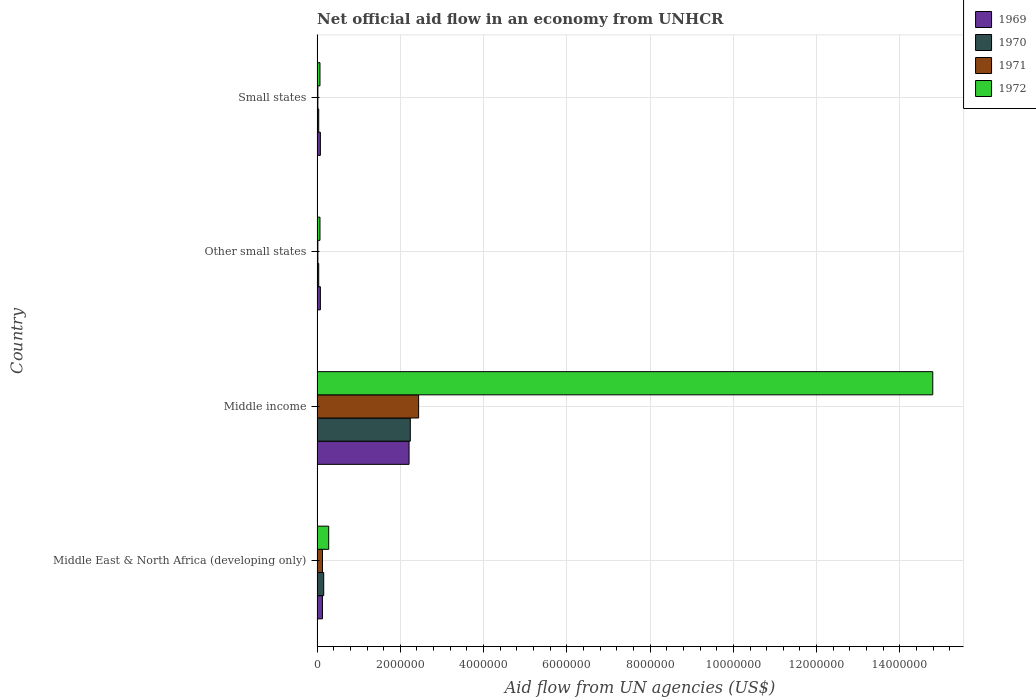How many different coloured bars are there?
Offer a very short reply. 4. Are the number of bars per tick equal to the number of legend labels?
Offer a very short reply. Yes. Are the number of bars on each tick of the Y-axis equal?
Keep it short and to the point. Yes. How many bars are there on the 4th tick from the top?
Offer a very short reply. 4. How many bars are there on the 2nd tick from the bottom?
Ensure brevity in your answer.  4. What is the label of the 2nd group of bars from the top?
Offer a terse response. Other small states. What is the net official aid flow in 1972 in Other small states?
Ensure brevity in your answer.  7.00e+04. Across all countries, what is the maximum net official aid flow in 1971?
Make the answer very short. 2.44e+06. In which country was the net official aid flow in 1970 maximum?
Ensure brevity in your answer.  Middle income. In which country was the net official aid flow in 1971 minimum?
Offer a terse response. Other small states. What is the total net official aid flow in 1971 in the graph?
Your answer should be compact. 2.61e+06. What is the difference between the net official aid flow in 1969 in Middle East & North Africa (developing only) and that in Other small states?
Ensure brevity in your answer.  5.00e+04. What is the average net official aid flow in 1971 per country?
Give a very brief answer. 6.52e+05. What is the difference between the net official aid flow in 1969 and net official aid flow in 1972 in Middle income?
Your response must be concise. -1.26e+07. What is the ratio of the net official aid flow in 1972 in Middle income to that in Other small states?
Your answer should be compact. 211.29. Is the net official aid flow in 1969 in Middle East & North Africa (developing only) less than that in Small states?
Give a very brief answer. No. What is the difference between the highest and the second highest net official aid flow in 1970?
Provide a short and direct response. 2.08e+06. What is the difference between the highest and the lowest net official aid flow in 1969?
Your response must be concise. 2.13e+06. In how many countries, is the net official aid flow in 1972 greater than the average net official aid flow in 1972 taken over all countries?
Your response must be concise. 1. Is the sum of the net official aid flow in 1969 in Middle income and Small states greater than the maximum net official aid flow in 1971 across all countries?
Your answer should be compact. No. Is it the case that in every country, the sum of the net official aid flow in 1969 and net official aid flow in 1970 is greater than the sum of net official aid flow in 1971 and net official aid flow in 1972?
Offer a very short reply. No. What does the 4th bar from the top in Middle East & North Africa (developing only) represents?
Your answer should be very brief. 1969. Are all the bars in the graph horizontal?
Your answer should be very brief. Yes. How many countries are there in the graph?
Offer a terse response. 4. Are the values on the major ticks of X-axis written in scientific E-notation?
Make the answer very short. No. Does the graph contain any zero values?
Ensure brevity in your answer.  No. Does the graph contain grids?
Make the answer very short. Yes. How many legend labels are there?
Give a very brief answer. 4. How are the legend labels stacked?
Make the answer very short. Vertical. What is the title of the graph?
Provide a short and direct response. Net official aid flow in an economy from UNHCR. What is the label or title of the X-axis?
Offer a terse response. Aid flow from UN agencies (US$). What is the Aid flow from UN agencies (US$) of 1969 in Middle East & North Africa (developing only)?
Your answer should be compact. 1.30e+05. What is the Aid flow from UN agencies (US$) in 1971 in Middle East & North Africa (developing only)?
Ensure brevity in your answer.  1.30e+05. What is the Aid flow from UN agencies (US$) in 1969 in Middle income?
Provide a short and direct response. 2.21e+06. What is the Aid flow from UN agencies (US$) of 1970 in Middle income?
Provide a succinct answer. 2.24e+06. What is the Aid flow from UN agencies (US$) of 1971 in Middle income?
Make the answer very short. 2.44e+06. What is the Aid flow from UN agencies (US$) in 1972 in Middle income?
Provide a short and direct response. 1.48e+07. What is the Aid flow from UN agencies (US$) of 1969 in Other small states?
Ensure brevity in your answer.  8.00e+04. What is the Aid flow from UN agencies (US$) in 1970 in Other small states?
Offer a terse response. 4.00e+04. What is the Aid flow from UN agencies (US$) of 1971 in Other small states?
Provide a short and direct response. 2.00e+04. What is the Aid flow from UN agencies (US$) of 1969 in Small states?
Ensure brevity in your answer.  8.00e+04. What is the Aid flow from UN agencies (US$) in 1971 in Small states?
Make the answer very short. 2.00e+04. Across all countries, what is the maximum Aid flow from UN agencies (US$) of 1969?
Provide a short and direct response. 2.21e+06. Across all countries, what is the maximum Aid flow from UN agencies (US$) of 1970?
Keep it short and to the point. 2.24e+06. Across all countries, what is the maximum Aid flow from UN agencies (US$) of 1971?
Keep it short and to the point. 2.44e+06. Across all countries, what is the maximum Aid flow from UN agencies (US$) of 1972?
Ensure brevity in your answer.  1.48e+07. Across all countries, what is the minimum Aid flow from UN agencies (US$) of 1969?
Provide a succinct answer. 8.00e+04. Across all countries, what is the minimum Aid flow from UN agencies (US$) in 1970?
Offer a very short reply. 4.00e+04. Across all countries, what is the minimum Aid flow from UN agencies (US$) of 1972?
Your response must be concise. 7.00e+04. What is the total Aid flow from UN agencies (US$) of 1969 in the graph?
Keep it short and to the point. 2.50e+06. What is the total Aid flow from UN agencies (US$) of 1970 in the graph?
Offer a very short reply. 2.48e+06. What is the total Aid flow from UN agencies (US$) of 1971 in the graph?
Provide a short and direct response. 2.61e+06. What is the total Aid flow from UN agencies (US$) of 1972 in the graph?
Provide a succinct answer. 1.52e+07. What is the difference between the Aid flow from UN agencies (US$) in 1969 in Middle East & North Africa (developing only) and that in Middle income?
Your response must be concise. -2.08e+06. What is the difference between the Aid flow from UN agencies (US$) in 1970 in Middle East & North Africa (developing only) and that in Middle income?
Provide a short and direct response. -2.08e+06. What is the difference between the Aid flow from UN agencies (US$) in 1971 in Middle East & North Africa (developing only) and that in Middle income?
Your answer should be compact. -2.31e+06. What is the difference between the Aid flow from UN agencies (US$) of 1972 in Middle East & North Africa (developing only) and that in Middle income?
Ensure brevity in your answer.  -1.45e+07. What is the difference between the Aid flow from UN agencies (US$) in 1969 in Middle East & North Africa (developing only) and that in Other small states?
Your response must be concise. 5.00e+04. What is the difference between the Aid flow from UN agencies (US$) in 1970 in Middle East & North Africa (developing only) and that in Other small states?
Keep it short and to the point. 1.20e+05. What is the difference between the Aid flow from UN agencies (US$) in 1972 in Middle East & North Africa (developing only) and that in Other small states?
Ensure brevity in your answer.  2.10e+05. What is the difference between the Aid flow from UN agencies (US$) in 1970 in Middle East & North Africa (developing only) and that in Small states?
Keep it short and to the point. 1.20e+05. What is the difference between the Aid flow from UN agencies (US$) in 1971 in Middle East & North Africa (developing only) and that in Small states?
Offer a very short reply. 1.10e+05. What is the difference between the Aid flow from UN agencies (US$) of 1969 in Middle income and that in Other small states?
Provide a short and direct response. 2.13e+06. What is the difference between the Aid flow from UN agencies (US$) in 1970 in Middle income and that in Other small states?
Provide a succinct answer. 2.20e+06. What is the difference between the Aid flow from UN agencies (US$) of 1971 in Middle income and that in Other small states?
Keep it short and to the point. 2.42e+06. What is the difference between the Aid flow from UN agencies (US$) of 1972 in Middle income and that in Other small states?
Make the answer very short. 1.47e+07. What is the difference between the Aid flow from UN agencies (US$) of 1969 in Middle income and that in Small states?
Your answer should be very brief. 2.13e+06. What is the difference between the Aid flow from UN agencies (US$) of 1970 in Middle income and that in Small states?
Your answer should be compact. 2.20e+06. What is the difference between the Aid flow from UN agencies (US$) in 1971 in Middle income and that in Small states?
Your answer should be very brief. 2.42e+06. What is the difference between the Aid flow from UN agencies (US$) in 1972 in Middle income and that in Small states?
Offer a very short reply. 1.47e+07. What is the difference between the Aid flow from UN agencies (US$) of 1969 in Other small states and that in Small states?
Provide a short and direct response. 0. What is the difference between the Aid flow from UN agencies (US$) of 1969 in Middle East & North Africa (developing only) and the Aid flow from UN agencies (US$) of 1970 in Middle income?
Give a very brief answer. -2.11e+06. What is the difference between the Aid flow from UN agencies (US$) of 1969 in Middle East & North Africa (developing only) and the Aid flow from UN agencies (US$) of 1971 in Middle income?
Keep it short and to the point. -2.31e+06. What is the difference between the Aid flow from UN agencies (US$) of 1969 in Middle East & North Africa (developing only) and the Aid flow from UN agencies (US$) of 1972 in Middle income?
Make the answer very short. -1.47e+07. What is the difference between the Aid flow from UN agencies (US$) in 1970 in Middle East & North Africa (developing only) and the Aid flow from UN agencies (US$) in 1971 in Middle income?
Provide a succinct answer. -2.28e+06. What is the difference between the Aid flow from UN agencies (US$) of 1970 in Middle East & North Africa (developing only) and the Aid flow from UN agencies (US$) of 1972 in Middle income?
Your answer should be very brief. -1.46e+07. What is the difference between the Aid flow from UN agencies (US$) in 1971 in Middle East & North Africa (developing only) and the Aid flow from UN agencies (US$) in 1972 in Middle income?
Your response must be concise. -1.47e+07. What is the difference between the Aid flow from UN agencies (US$) of 1969 in Middle East & North Africa (developing only) and the Aid flow from UN agencies (US$) of 1970 in Other small states?
Keep it short and to the point. 9.00e+04. What is the difference between the Aid flow from UN agencies (US$) of 1969 in Middle East & North Africa (developing only) and the Aid flow from UN agencies (US$) of 1972 in Other small states?
Your answer should be very brief. 6.00e+04. What is the difference between the Aid flow from UN agencies (US$) of 1970 in Middle East & North Africa (developing only) and the Aid flow from UN agencies (US$) of 1971 in Other small states?
Give a very brief answer. 1.40e+05. What is the difference between the Aid flow from UN agencies (US$) in 1971 in Middle East & North Africa (developing only) and the Aid flow from UN agencies (US$) in 1972 in Other small states?
Keep it short and to the point. 6.00e+04. What is the difference between the Aid flow from UN agencies (US$) in 1969 in Middle East & North Africa (developing only) and the Aid flow from UN agencies (US$) in 1970 in Small states?
Your response must be concise. 9.00e+04. What is the difference between the Aid flow from UN agencies (US$) of 1969 in Middle East & North Africa (developing only) and the Aid flow from UN agencies (US$) of 1972 in Small states?
Your response must be concise. 6.00e+04. What is the difference between the Aid flow from UN agencies (US$) of 1970 in Middle East & North Africa (developing only) and the Aid flow from UN agencies (US$) of 1971 in Small states?
Provide a short and direct response. 1.40e+05. What is the difference between the Aid flow from UN agencies (US$) of 1970 in Middle East & North Africa (developing only) and the Aid flow from UN agencies (US$) of 1972 in Small states?
Ensure brevity in your answer.  9.00e+04. What is the difference between the Aid flow from UN agencies (US$) in 1971 in Middle East & North Africa (developing only) and the Aid flow from UN agencies (US$) in 1972 in Small states?
Offer a very short reply. 6.00e+04. What is the difference between the Aid flow from UN agencies (US$) in 1969 in Middle income and the Aid flow from UN agencies (US$) in 1970 in Other small states?
Your answer should be very brief. 2.17e+06. What is the difference between the Aid flow from UN agencies (US$) in 1969 in Middle income and the Aid flow from UN agencies (US$) in 1971 in Other small states?
Provide a short and direct response. 2.19e+06. What is the difference between the Aid flow from UN agencies (US$) in 1969 in Middle income and the Aid flow from UN agencies (US$) in 1972 in Other small states?
Provide a short and direct response. 2.14e+06. What is the difference between the Aid flow from UN agencies (US$) of 1970 in Middle income and the Aid flow from UN agencies (US$) of 1971 in Other small states?
Provide a short and direct response. 2.22e+06. What is the difference between the Aid flow from UN agencies (US$) of 1970 in Middle income and the Aid flow from UN agencies (US$) of 1972 in Other small states?
Provide a short and direct response. 2.17e+06. What is the difference between the Aid flow from UN agencies (US$) of 1971 in Middle income and the Aid flow from UN agencies (US$) of 1972 in Other small states?
Make the answer very short. 2.37e+06. What is the difference between the Aid flow from UN agencies (US$) in 1969 in Middle income and the Aid flow from UN agencies (US$) in 1970 in Small states?
Provide a short and direct response. 2.17e+06. What is the difference between the Aid flow from UN agencies (US$) in 1969 in Middle income and the Aid flow from UN agencies (US$) in 1971 in Small states?
Your answer should be compact. 2.19e+06. What is the difference between the Aid flow from UN agencies (US$) of 1969 in Middle income and the Aid flow from UN agencies (US$) of 1972 in Small states?
Make the answer very short. 2.14e+06. What is the difference between the Aid flow from UN agencies (US$) of 1970 in Middle income and the Aid flow from UN agencies (US$) of 1971 in Small states?
Give a very brief answer. 2.22e+06. What is the difference between the Aid flow from UN agencies (US$) in 1970 in Middle income and the Aid flow from UN agencies (US$) in 1972 in Small states?
Your answer should be compact. 2.17e+06. What is the difference between the Aid flow from UN agencies (US$) in 1971 in Middle income and the Aid flow from UN agencies (US$) in 1972 in Small states?
Give a very brief answer. 2.37e+06. What is the difference between the Aid flow from UN agencies (US$) in 1970 in Other small states and the Aid flow from UN agencies (US$) in 1971 in Small states?
Offer a very short reply. 2.00e+04. What is the difference between the Aid flow from UN agencies (US$) of 1971 in Other small states and the Aid flow from UN agencies (US$) of 1972 in Small states?
Your answer should be compact. -5.00e+04. What is the average Aid flow from UN agencies (US$) of 1969 per country?
Make the answer very short. 6.25e+05. What is the average Aid flow from UN agencies (US$) in 1970 per country?
Your response must be concise. 6.20e+05. What is the average Aid flow from UN agencies (US$) in 1971 per country?
Your answer should be very brief. 6.52e+05. What is the average Aid flow from UN agencies (US$) in 1972 per country?
Your answer should be compact. 3.80e+06. What is the difference between the Aid flow from UN agencies (US$) in 1970 and Aid flow from UN agencies (US$) in 1972 in Middle East & North Africa (developing only)?
Provide a succinct answer. -1.20e+05. What is the difference between the Aid flow from UN agencies (US$) of 1971 and Aid flow from UN agencies (US$) of 1972 in Middle East & North Africa (developing only)?
Provide a short and direct response. -1.50e+05. What is the difference between the Aid flow from UN agencies (US$) of 1969 and Aid flow from UN agencies (US$) of 1970 in Middle income?
Ensure brevity in your answer.  -3.00e+04. What is the difference between the Aid flow from UN agencies (US$) of 1969 and Aid flow from UN agencies (US$) of 1972 in Middle income?
Offer a very short reply. -1.26e+07. What is the difference between the Aid flow from UN agencies (US$) of 1970 and Aid flow from UN agencies (US$) of 1971 in Middle income?
Offer a very short reply. -2.00e+05. What is the difference between the Aid flow from UN agencies (US$) of 1970 and Aid flow from UN agencies (US$) of 1972 in Middle income?
Offer a terse response. -1.26e+07. What is the difference between the Aid flow from UN agencies (US$) of 1971 and Aid flow from UN agencies (US$) of 1972 in Middle income?
Make the answer very short. -1.24e+07. What is the difference between the Aid flow from UN agencies (US$) of 1969 and Aid flow from UN agencies (US$) of 1970 in Other small states?
Make the answer very short. 4.00e+04. What is the difference between the Aid flow from UN agencies (US$) of 1969 and Aid flow from UN agencies (US$) of 1972 in Other small states?
Your answer should be compact. 10000. What is the difference between the Aid flow from UN agencies (US$) in 1970 and Aid flow from UN agencies (US$) in 1972 in Other small states?
Your answer should be compact. -3.00e+04. What is the difference between the Aid flow from UN agencies (US$) in 1969 and Aid flow from UN agencies (US$) in 1971 in Small states?
Give a very brief answer. 6.00e+04. What is the difference between the Aid flow from UN agencies (US$) of 1969 and Aid flow from UN agencies (US$) of 1972 in Small states?
Provide a short and direct response. 10000. What is the difference between the Aid flow from UN agencies (US$) of 1970 and Aid flow from UN agencies (US$) of 1971 in Small states?
Your response must be concise. 2.00e+04. What is the difference between the Aid flow from UN agencies (US$) of 1970 and Aid flow from UN agencies (US$) of 1972 in Small states?
Provide a succinct answer. -3.00e+04. What is the ratio of the Aid flow from UN agencies (US$) in 1969 in Middle East & North Africa (developing only) to that in Middle income?
Offer a terse response. 0.06. What is the ratio of the Aid flow from UN agencies (US$) in 1970 in Middle East & North Africa (developing only) to that in Middle income?
Provide a short and direct response. 0.07. What is the ratio of the Aid flow from UN agencies (US$) of 1971 in Middle East & North Africa (developing only) to that in Middle income?
Provide a short and direct response. 0.05. What is the ratio of the Aid flow from UN agencies (US$) in 1972 in Middle East & North Africa (developing only) to that in Middle income?
Your answer should be compact. 0.02. What is the ratio of the Aid flow from UN agencies (US$) of 1969 in Middle East & North Africa (developing only) to that in Other small states?
Provide a succinct answer. 1.62. What is the ratio of the Aid flow from UN agencies (US$) in 1970 in Middle East & North Africa (developing only) to that in Other small states?
Ensure brevity in your answer.  4. What is the ratio of the Aid flow from UN agencies (US$) in 1969 in Middle East & North Africa (developing only) to that in Small states?
Your answer should be very brief. 1.62. What is the ratio of the Aid flow from UN agencies (US$) in 1972 in Middle East & North Africa (developing only) to that in Small states?
Your answer should be compact. 4. What is the ratio of the Aid flow from UN agencies (US$) of 1969 in Middle income to that in Other small states?
Your answer should be very brief. 27.62. What is the ratio of the Aid flow from UN agencies (US$) of 1971 in Middle income to that in Other small states?
Provide a succinct answer. 122. What is the ratio of the Aid flow from UN agencies (US$) of 1972 in Middle income to that in Other small states?
Keep it short and to the point. 211.29. What is the ratio of the Aid flow from UN agencies (US$) in 1969 in Middle income to that in Small states?
Offer a very short reply. 27.62. What is the ratio of the Aid flow from UN agencies (US$) of 1971 in Middle income to that in Small states?
Keep it short and to the point. 122. What is the ratio of the Aid flow from UN agencies (US$) in 1972 in Middle income to that in Small states?
Keep it short and to the point. 211.29. What is the ratio of the Aid flow from UN agencies (US$) of 1969 in Other small states to that in Small states?
Provide a succinct answer. 1. What is the ratio of the Aid flow from UN agencies (US$) in 1970 in Other small states to that in Small states?
Provide a short and direct response. 1. What is the ratio of the Aid flow from UN agencies (US$) of 1971 in Other small states to that in Small states?
Give a very brief answer. 1. What is the difference between the highest and the second highest Aid flow from UN agencies (US$) of 1969?
Your answer should be compact. 2.08e+06. What is the difference between the highest and the second highest Aid flow from UN agencies (US$) in 1970?
Give a very brief answer. 2.08e+06. What is the difference between the highest and the second highest Aid flow from UN agencies (US$) of 1971?
Provide a succinct answer. 2.31e+06. What is the difference between the highest and the second highest Aid flow from UN agencies (US$) of 1972?
Give a very brief answer. 1.45e+07. What is the difference between the highest and the lowest Aid flow from UN agencies (US$) of 1969?
Provide a succinct answer. 2.13e+06. What is the difference between the highest and the lowest Aid flow from UN agencies (US$) in 1970?
Your response must be concise. 2.20e+06. What is the difference between the highest and the lowest Aid flow from UN agencies (US$) in 1971?
Your answer should be very brief. 2.42e+06. What is the difference between the highest and the lowest Aid flow from UN agencies (US$) of 1972?
Provide a succinct answer. 1.47e+07. 